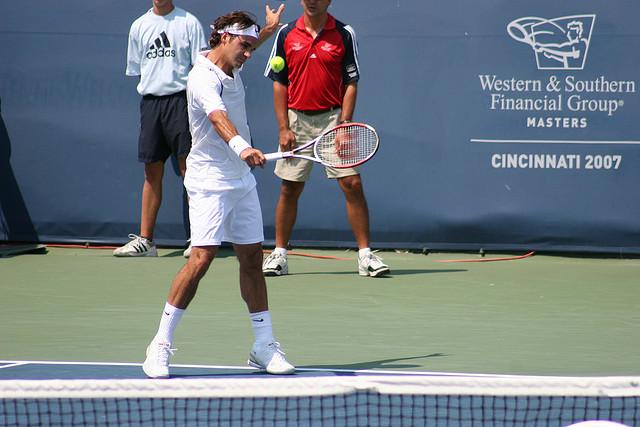Who is the sponsor?
Quick response, please. Western & southern financial group. What is the name of the tennis tour?
Keep it brief. Masters. What is the job for the person wearing red?
Be succinct. Ball boy. What does the man have on his head?
Keep it brief. Headband. What city is this match being played in?
Give a very brief answer. Cincinnati. What color shirt is the man wearing?
Be succinct. White. What year was this tennis match taking place in?
Give a very brief answer. 2007. How old is the tennis player?
Give a very brief answer. 30. 